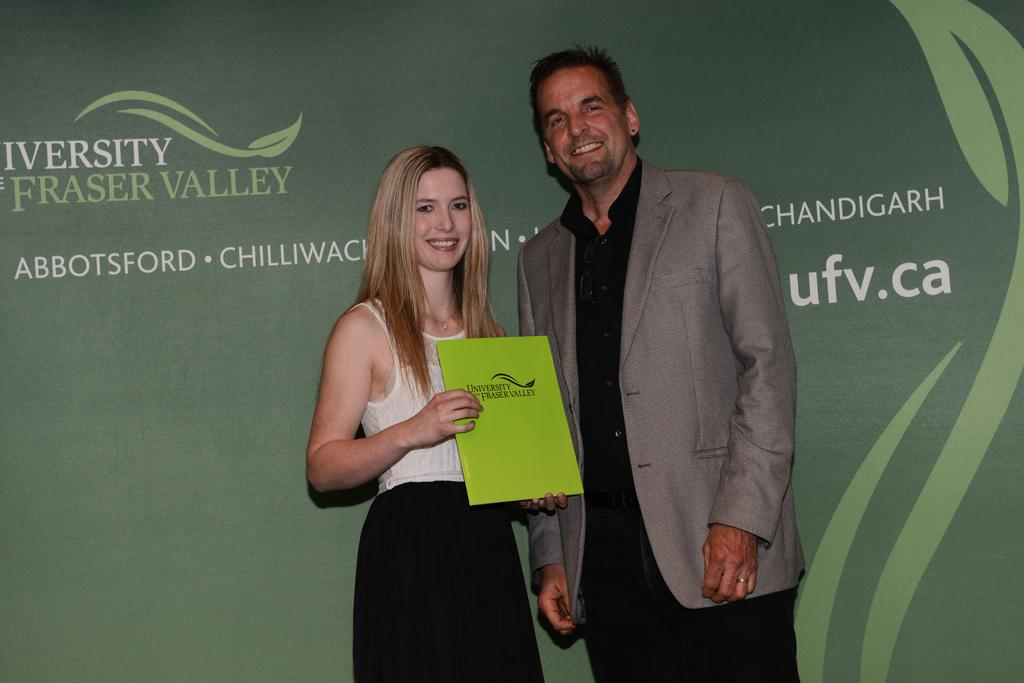How many people are present in the image? There are two people, a man and a woman, present in the image. What is the woman holding in the image? The woman is holding a card with text on it. Is there any text visible in the image? Yes, there is a banner with text visible in the image. What type of army uniform is the man wearing in the image? There is no army uniform or any reference to an army in the image. 